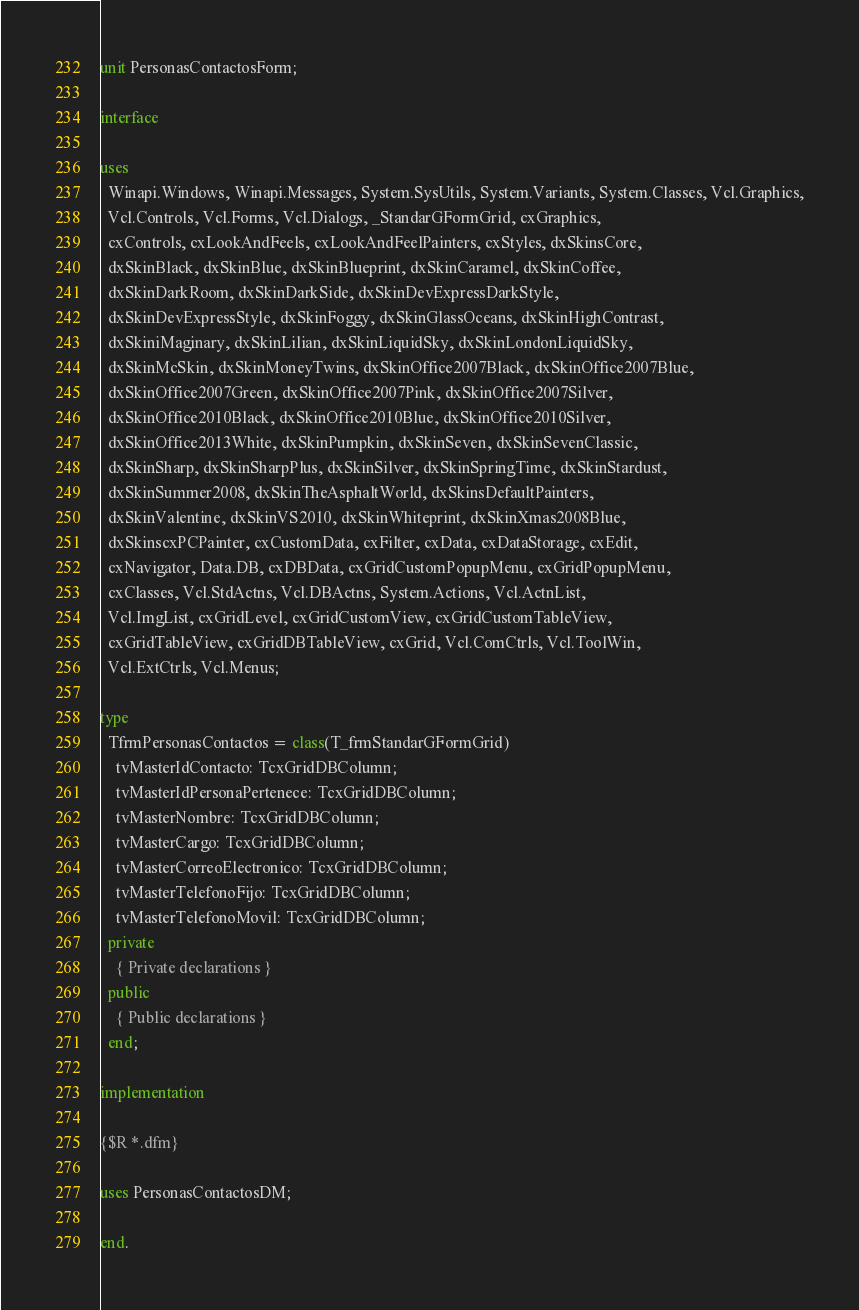<code> <loc_0><loc_0><loc_500><loc_500><_Pascal_>unit PersonasContactosForm;

interface

uses
  Winapi.Windows, Winapi.Messages, System.SysUtils, System.Variants, System.Classes, Vcl.Graphics,
  Vcl.Controls, Vcl.Forms, Vcl.Dialogs, _StandarGFormGrid, cxGraphics,
  cxControls, cxLookAndFeels, cxLookAndFeelPainters, cxStyles, dxSkinsCore,
  dxSkinBlack, dxSkinBlue, dxSkinBlueprint, dxSkinCaramel, dxSkinCoffee,
  dxSkinDarkRoom, dxSkinDarkSide, dxSkinDevExpressDarkStyle,
  dxSkinDevExpressStyle, dxSkinFoggy, dxSkinGlassOceans, dxSkinHighContrast,
  dxSkiniMaginary, dxSkinLilian, dxSkinLiquidSky, dxSkinLondonLiquidSky,
  dxSkinMcSkin, dxSkinMoneyTwins, dxSkinOffice2007Black, dxSkinOffice2007Blue,
  dxSkinOffice2007Green, dxSkinOffice2007Pink, dxSkinOffice2007Silver,
  dxSkinOffice2010Black, dxSkinOffice2010Blue, dxSkinOffice2010Silver,
  dxSkinOffice2013White, dxSkinPumpkin, dxSkinSeven, dxSkinSevenClassic,
  dxSkinSharp, dxSkinSharpPlus, dxSkinSilver, dxSkinSpringTime, dxSkinStardust,
  dxSkinSummer2008, dxSkinTheAsphaltWorld, dxSkinsDefaultPainters,
  dxSkinValentine, dxSkinVS2010, dxSkinWhiteprint, dxSkinXmas2008Blue,
  dxSkinscxPCPainter, cxCustomData, cxFilter, cxData, cxDataStorage, cxEdit,
  cxNavigator, Data.DB, cxDBData, cxGridCustomPopupMenu, cxGridPopupMenu,
  cxClasses, Vcl.StdActns, Vcl.DBActns, System.Actions, Vcl.ActnList,
  Vcl.ImgList, cxGridLevel, cxGridCustomView, cxGridCustomTableView,
  cxGridTableView, cxGridDBTableView, cxGrid, Vcl.ComCtrls, Vcl.ToolWin,
  Vcl.ExtCtrls, Vcl.Menus;

type
  TfrmPersonasContactos = class(T_frmStandarGFormGrid)
    tvMasterIdContacto: TcxGridDBColumn;
    tvMasterIdPersonaPertenece: TcxGridDBColumn;
    tvMasterNombre: TcxGridDBColumn;
    tvMasterCargo: TcxGridDBColumn;
    tvMasterCorreoElectronico: TcxGridDBColumn;
    tvMasterTelefonoFijo: TcxGridDBColumn;
    tvMasterTelefonoMovil: TcxGridDBColumn;
  private
    { Private declarations }
  public
    { Public declarations }
  end;

implementation

{$R *.dfm}

uses PersonasContactosDM;

end.
</code> 